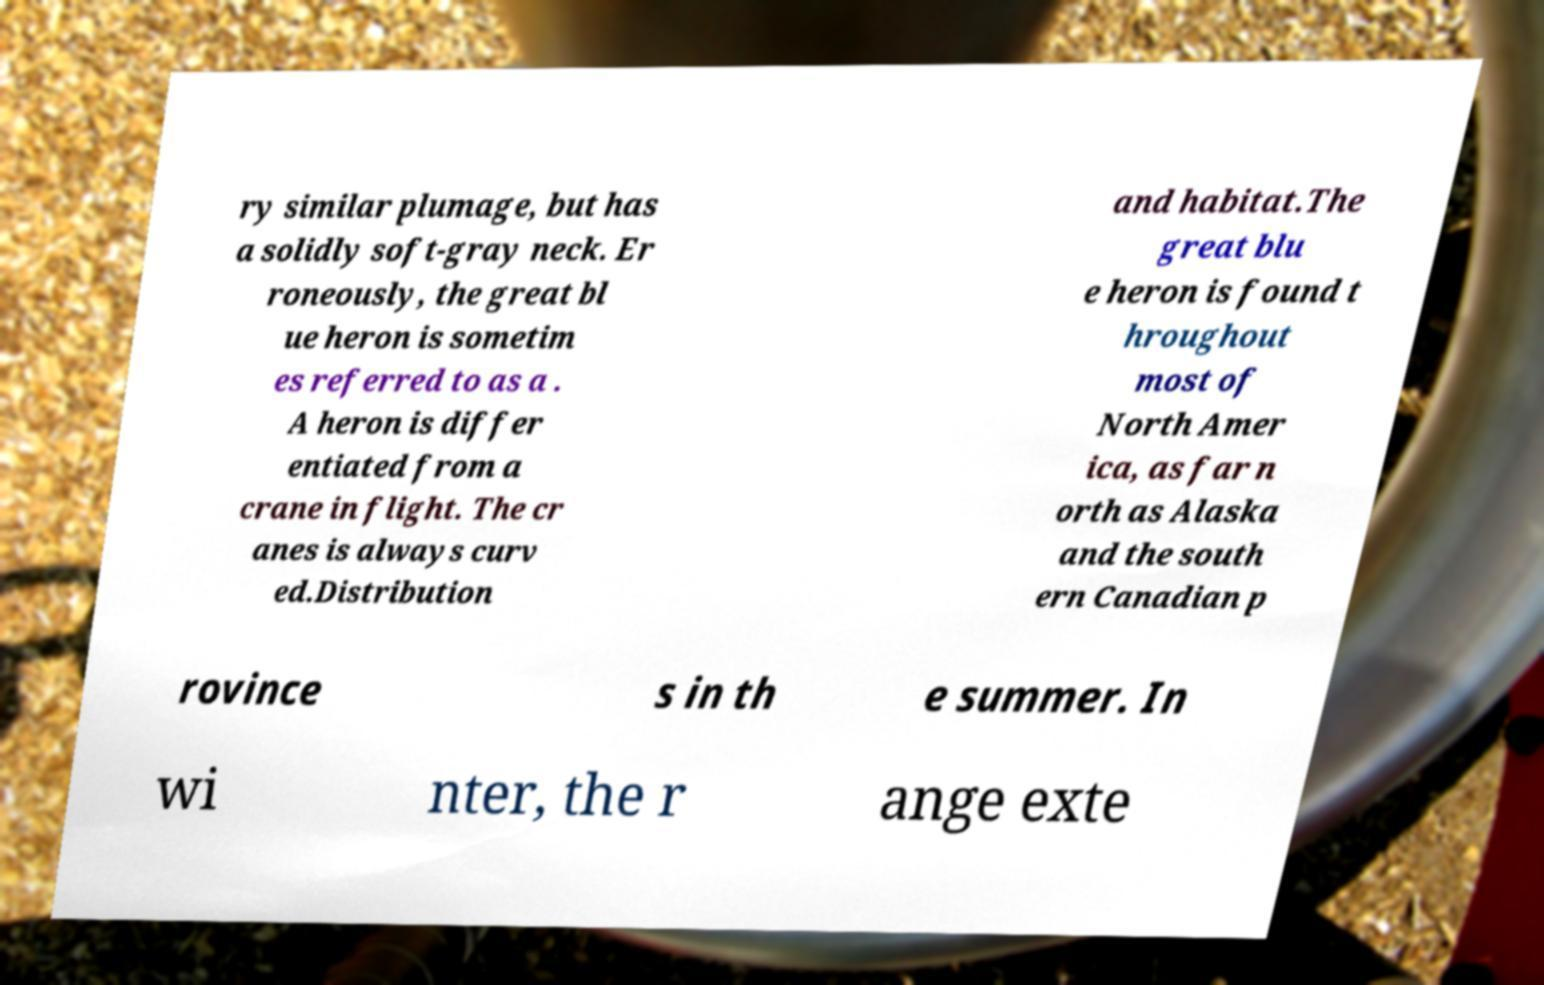For documentation purposes, I need the text within this image transcribed. Could you provide that? ry similar plumage, but has a solidly soft-gray neck. Er roneously, the great bl ue heron is sometim es referred to as a . A heron is differ entiated from a crane in flight. The cr anes is always curv ed.Distribution and habitat.The great blu e heron is found t hroughout most of North Amer ica, as far n orth as Alaska and the south ern Canadian p rovince s in th e summer. In wi nter, the r ange exte 